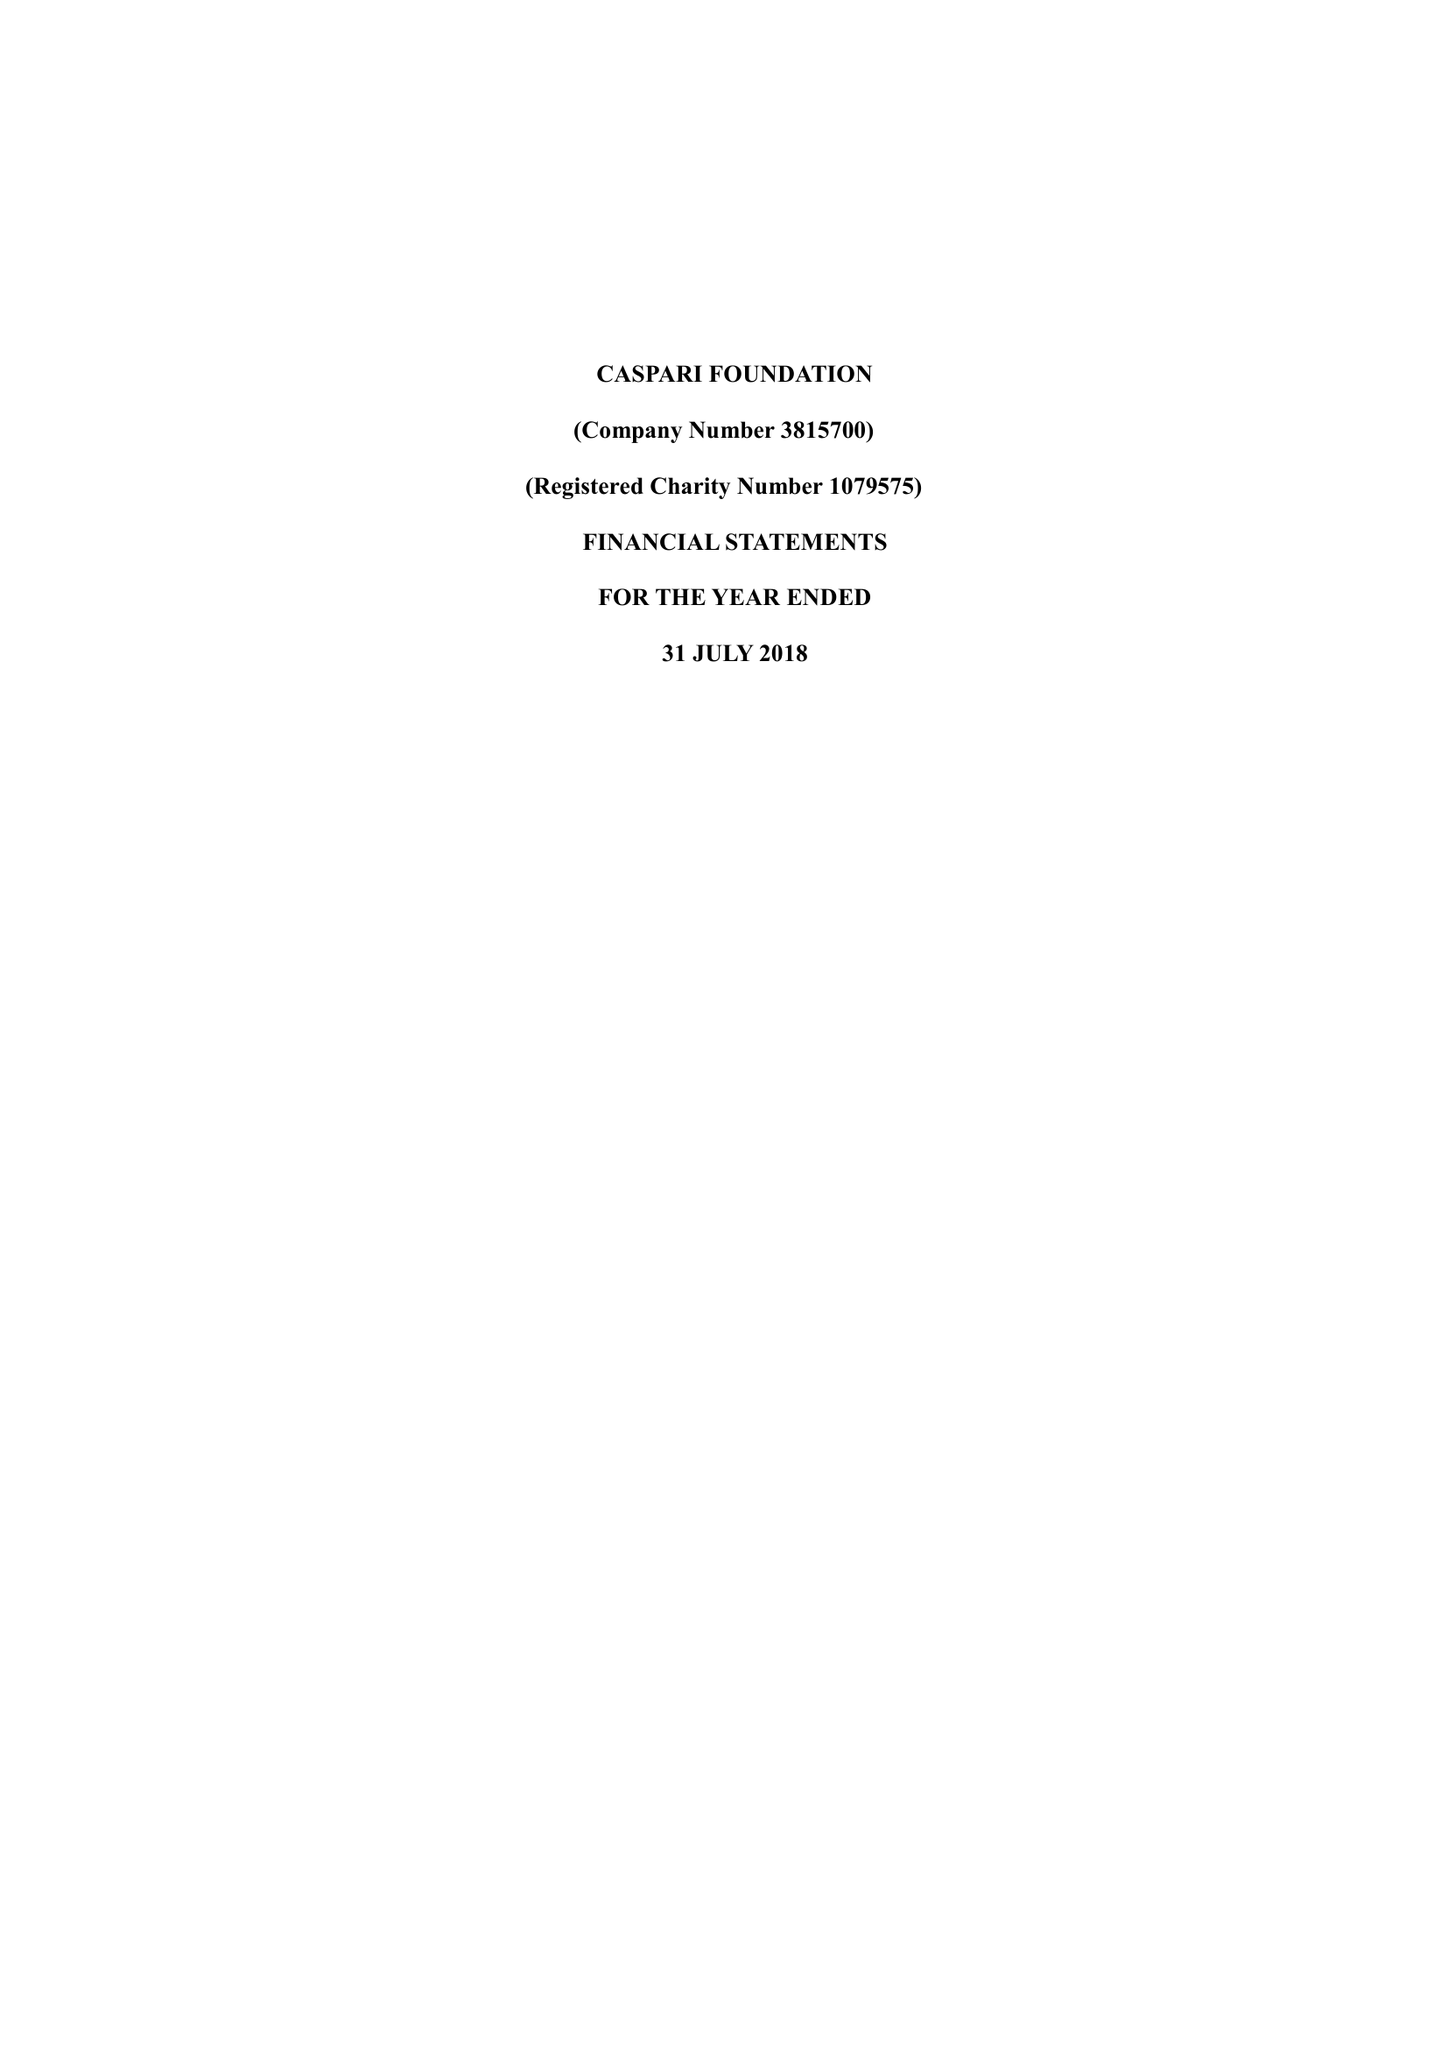What is the value for the report_date?
Answer the question using a single word or phrase. 2018-07-31 